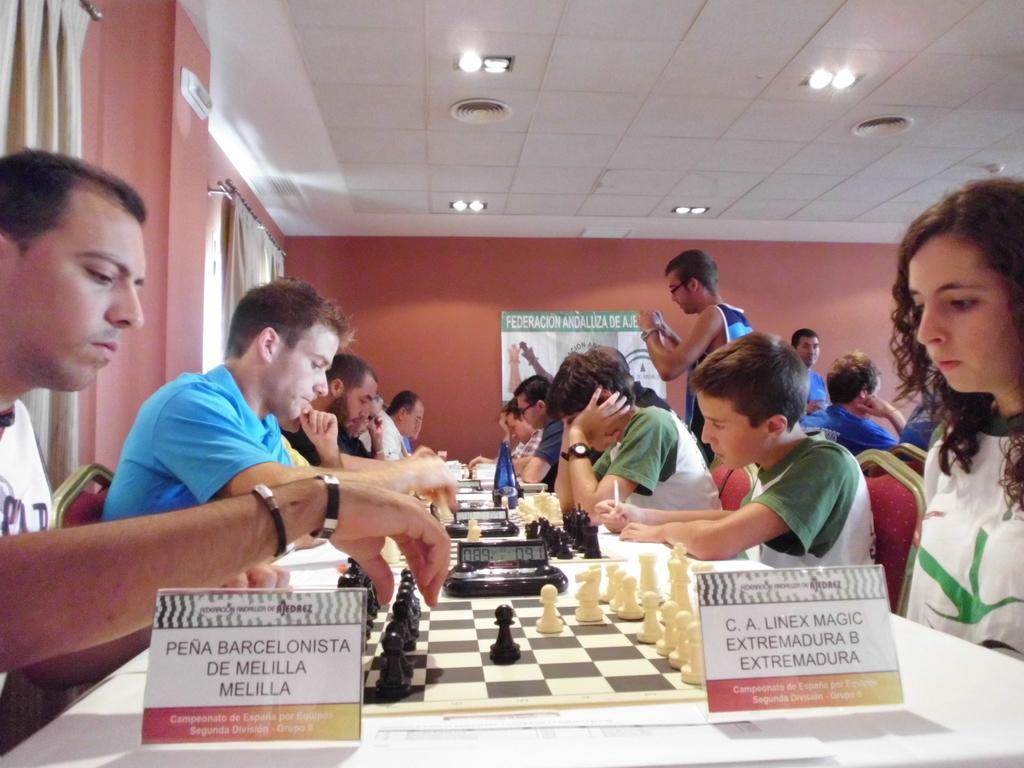Describe this image in one or two sentences. This is the picture inside of the room. There are group of people sitting at the table. There are chess boards, devices, bottles on the table. There are playing chess. At the back there is a poster on the wall. At the left there are curtains. At the top there are lights. 